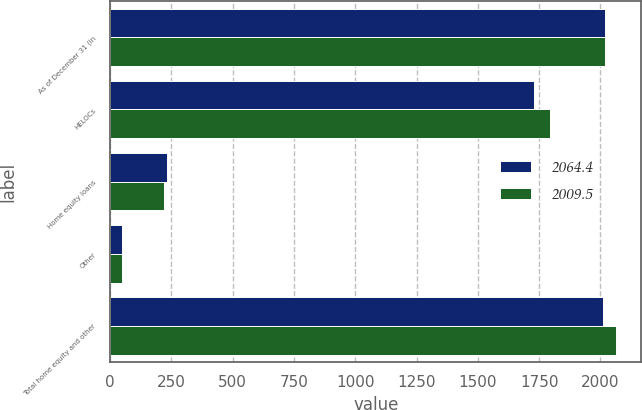<chart> <loc_0><loc_0><loc_500><loc_500><stacked_bar_chart><ecel><fcel>As of December 31 (in<fcel>HELOCs<fcel>Home equity loans<fcel>Other<fcel>Total home equity and other<nl><fcel>2064.4<fcel>2018<fcel>1729.9<fcel>232.5<fcel>47.1<fcel>2009.5<nl><fcel>2009.5<fcel>2017<fcel>1796.1<fcel>219.1<fcel>49.2<fcel>2064.4<nl></chart> 